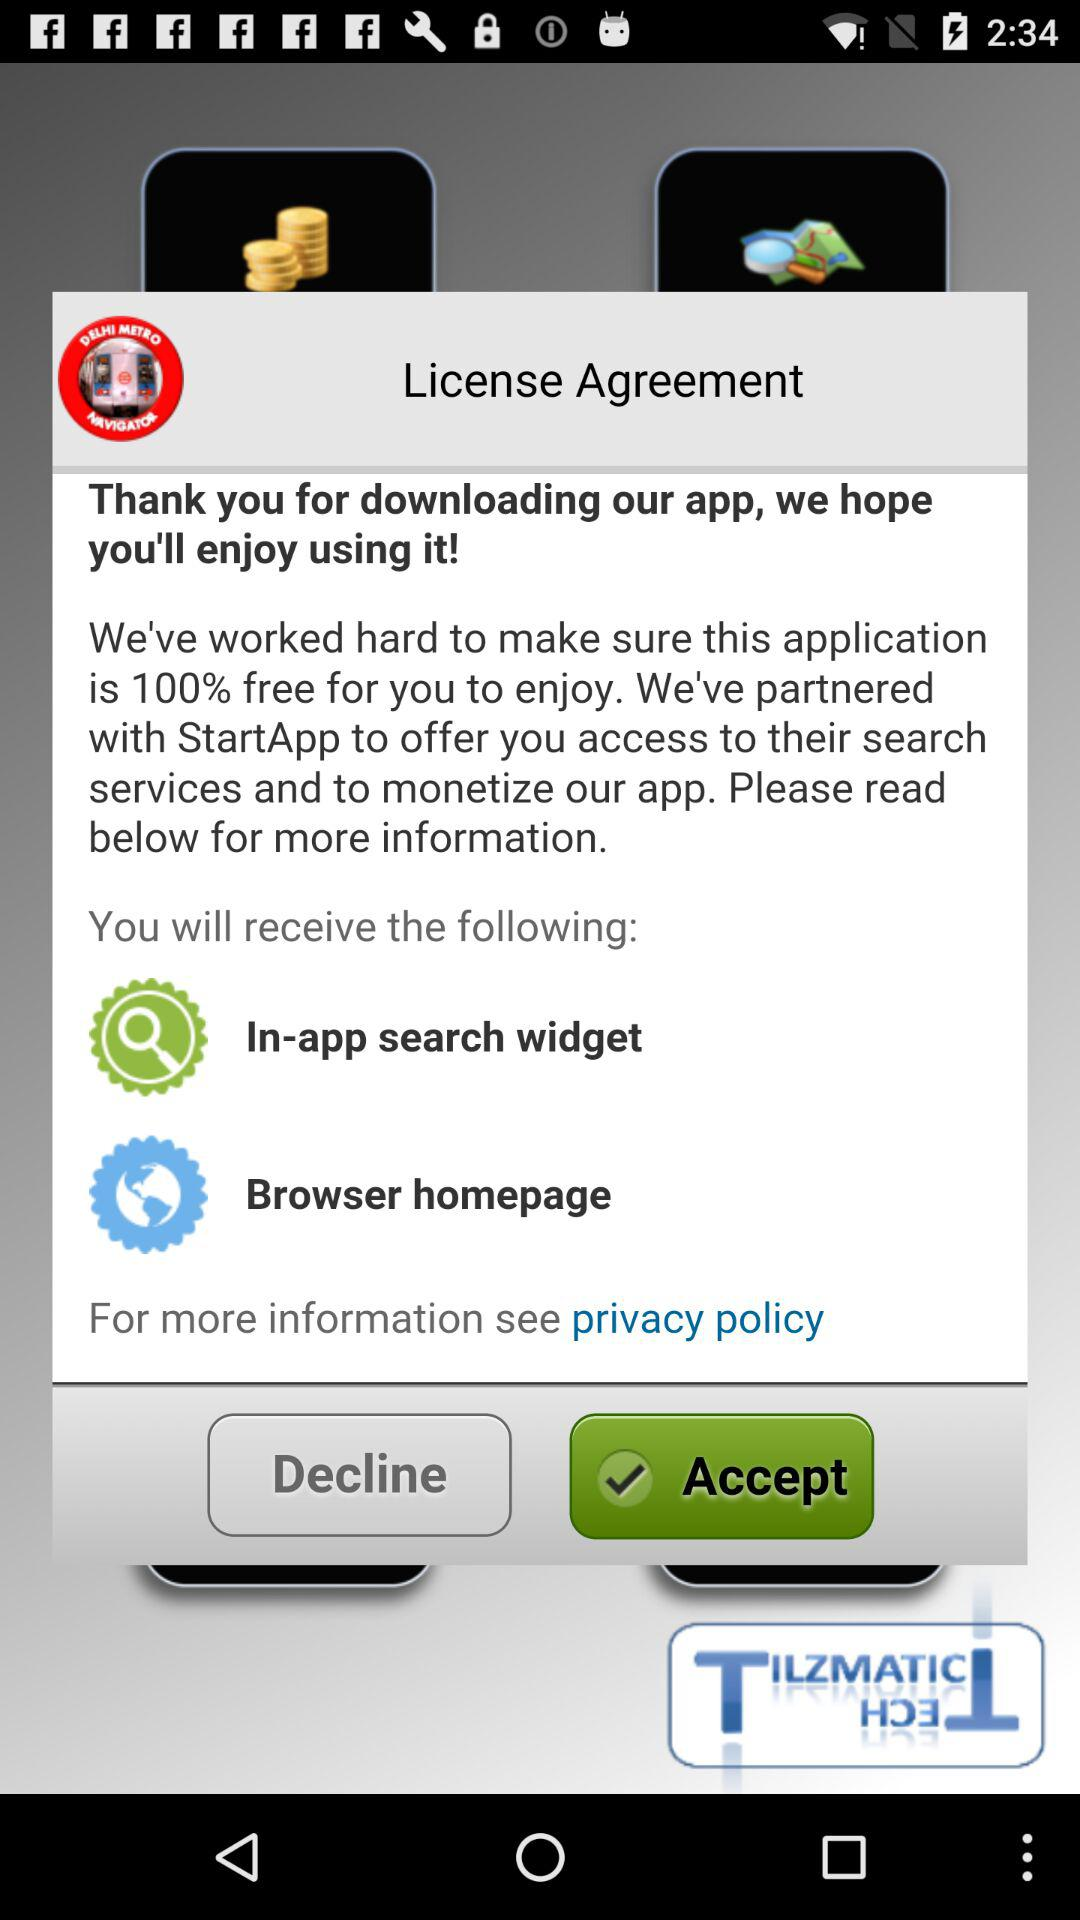What is the partnered app? The partnered app is "StartApp". 